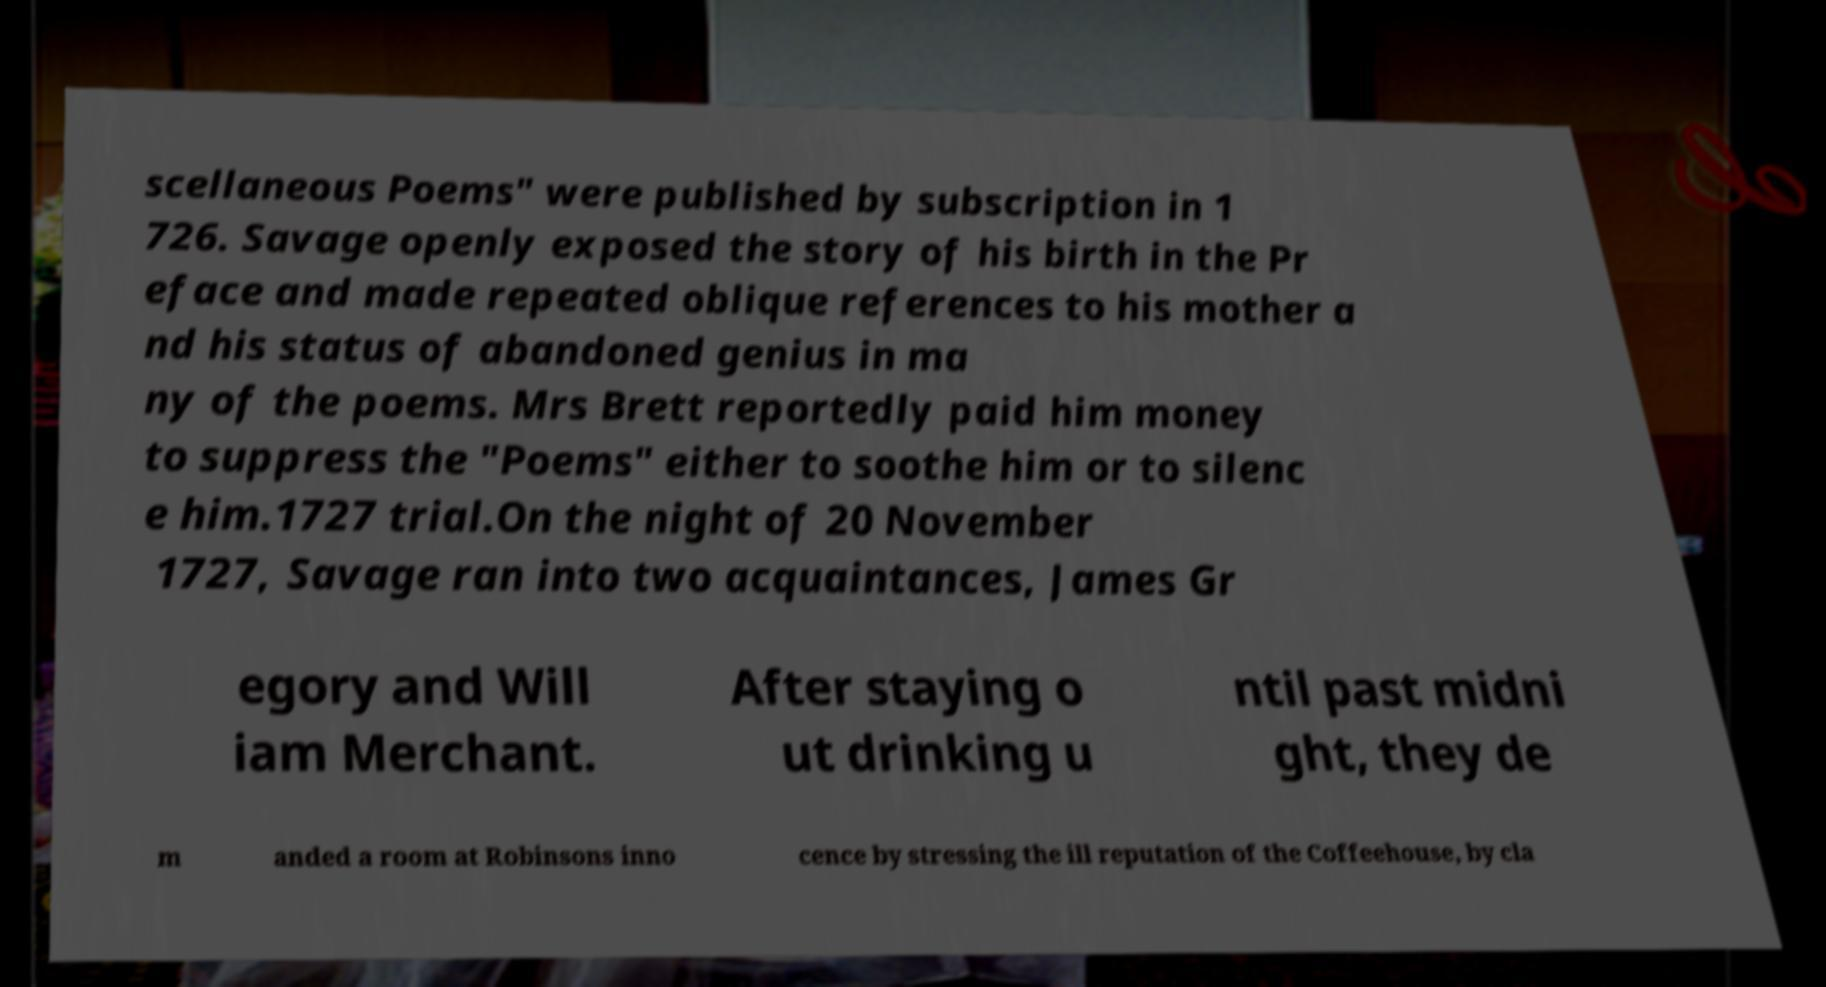What messages or text are displayed in this image? I need them in a readable, typed format. scellaneous Poems" were published by subscription in 1 726. Savage openly exposed the story of his birth in the Pr eface and made repeated oblique references to his mother a nd his status of abandoned genius in ma ny of the poems. Mrs Brett reportedly paid him money to suppress the "Poems" either to soothe him or to silenc e him.1727 trial.On the night of 20 November 1727, Savage ran into two acquaintances, James Gr egory and Will iam Merchant. After staying o ut drinking u ntil past midni ght, they de m anded a room at Robinsons inno cence by stressing the ill reputation of the Coffeehouse, by cla 